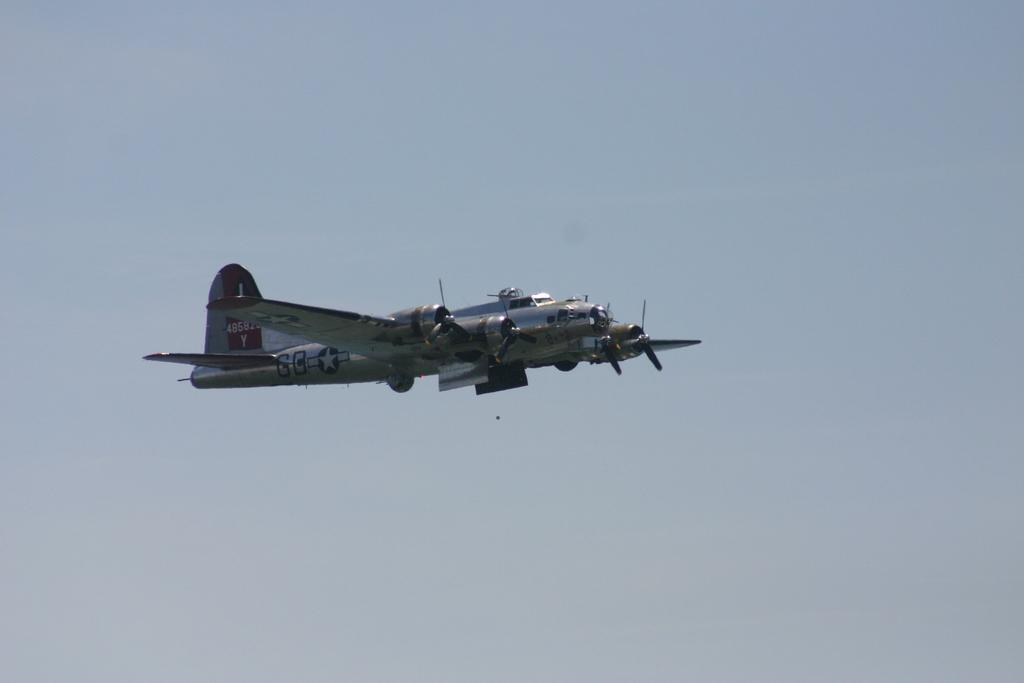Provide a one-sentence caption for the provided image. A prop airplane flying with the letters GB displayed on the side. 